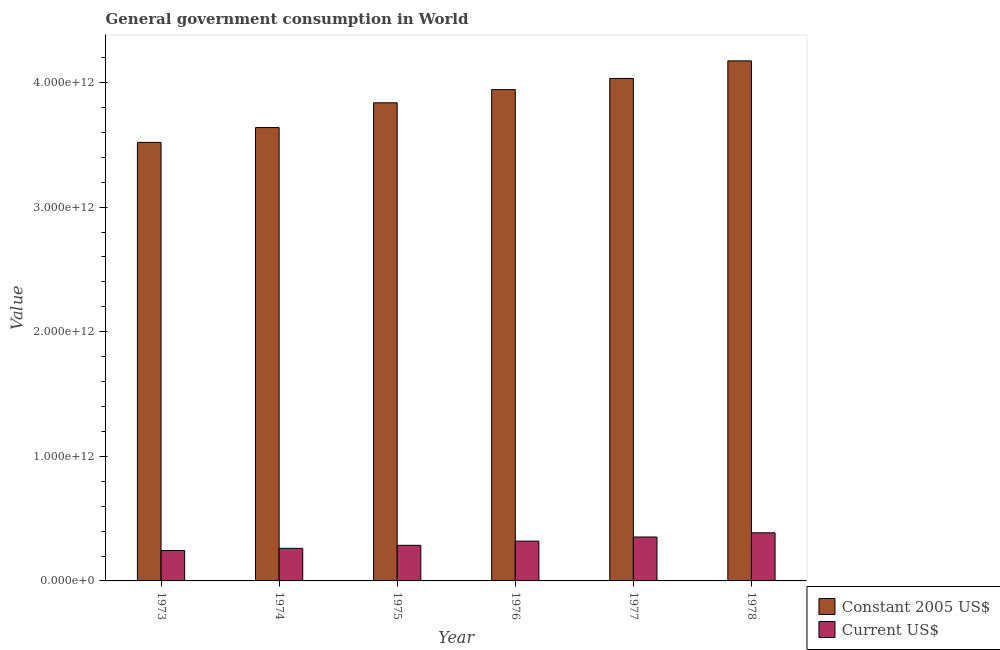Are the number of bars per tick equal to the number of legend labels?
Offer a terse response. Yes. How many bars are there on the 2nd tick from the left?
Your answer should be very brief. 2. In how many cases, is the number of bars for a given year not equal to the number of legend labels?
Keep it short and to the point. 0. What is the value consumed in constant 2005 us$ in 1977?
Provide a short and direct response. 4.03e+12. Across all years, what is the maximum value consumed in constant 2005 us$?
Your answer should be compact. 4.17e+12. Across all years, what is the minimum value consumed in current us$?
Give a very brief answer. 2.44e+11. In which year was the value consumed in current us$ maximum?
Make the answer very short. 1978. In which year was the value consumed in constant 2005 us$ minimum?
Give a very brief answer. 1973. What is the total value consumed in current us$ in the graph?
Your answer should be very brief. 1.85e+12. What is the difference between the value consumed in current us$ in 1973 and that in 1977?
Give a very brief answer. -1.08e+11. What is the difference between the value consumed in constant 2005 us$ in 1978 and the value consumed in current us$ in 1973?
Your answer should be very brief. 6.54e+11. What is the average value consumed in current us$ per year?
Offer a very short reply. 3.08e+11. In how many years, is the value consumed in constant 2005 us$ greater than 2200000000000?
Offer a very short reply. 6. What is the ratio of the value consumed in current us$ in 1973 to that in 1974?
Provide a short and direct response. 0.93. Is the difference between the value consumed in current us$ in 1973 and 1975 greater than the difference between the value consumed in constant 2005 us$ in 1973 and 1975?
Provide a short and direct response. No. What is the difference between the highest and the second highest value consumed in current us$?
Provide a succinct answer. 3.37e+1. What is the difference between the highest and the lowest value consumed in current us$?
Provide a succinct answer. 1.42e+11. Is the sum of the value consumed in constant 2005 us$ in 1973 and 1974 greater than the maximum value consumed in current us$ across all years?
Make the answer very short. Yes. What does the 1st bar from the left in 1976 represents?
Offer a very short reply. Constant 2005 US$. What does the 2nd bar from the right in 1978 represents?
Make the answer very short. Constant 2005 US$. How many bars are there?
Give a very brief answer. 12. What is the difference between two consecutive major ticks on the Y-axis?
Keep it short and to the point. 1.00e+12. Where does the legend appear in the graph?
Keep it short and to the point. Bottom right. How many legend labels are there?
Offer a terse response. 2. What is the title of the graph?
Keep it short and to the point. General government consumption in World. What is the label or title of the Y-axis?
Your answer should be very brief. Value. What is the Value of Constant 2005 US$ in 1973?
Give a very brief answer. 3.52e+12. What is the Value in Current US$ in 1973?
Provide a succinct answer. 2.44e+11. What is the Value in Constant 2005 US$ in 1974?
Offer a terse response. 3.64e+12. What is the Value of Current US$ in 1974?
Provide a succinct answer. 2.61e+11. What is the Value in Constant 2005 US$ in 1975?
Keep it short and to the point. 3.84e+12. What is the Value of Current US$ in 1975?
Offer a terse response. 2.86e+11. What is the Value in Constant 2005 US$ in 1976?
Your answer should be compact. 3.94e+12. What is the Value of Current US$ in 1976?
Your response must be concise. 3.19e+11. What is the Value of Constant 2005 US$ in 1977?
Your answer should be very brief. 4.03e+12. What is the Value of Current US$ in 1977?
Give a very brief answer. 3.52e+11. What is the Value of Constant 2005 US$ in 1978?
Make the answer very short. 4.17e+12. What is the Value in Current US$ in 1978?
Your response must be concise. 3.86e+11. Across all years, what is the maximum Value of Constant 2005 US$?
Give a very brief answer. 4.17e+12. Across all years, what is the maximum Value of Current US$?
Ensure brevity in your answer.  3.86e+11. Across all years, what is the minimum Value of Constant 2005 US$?
Provide a short and direct response. 3.52e+12. Across all years, what is the minimum Value of Current US$?
Provide a succinct answer. 2.44e+11. What is the total Value of Constant 2005 US$ in the graph?
Give a very brief answer. 2.31e+13. What is the total Value of Current US$ in the graph?
Keep it short and to the point. 1.85e+12. What is the difference between the Value in Constant 2005 US$ in 1973 and that in 1974?
Your answer should be compact. -1.19e+11. What is the difference between the Value of Current US$ in 1973 and that in 1974?
Offer a terse response. -1.73e+1. What is the difference between the Value of Constant 2005 US$ in 1973 and that in 1975?
Your answer should be compact. -3.18e+11. What is the difference between the Value of Current US$ in 1973 and that in 1975?
Offer a terse response. -4.16e+1. What is the difference between the Value in Constant 2005 US$ in 1973 and that in 1976?
Make the answer very short. -4.24e+11. What is the difference between the Value of Current US$ in 1973 and that in 1976?
Offer a terse response. -7.55e+1. What is the difference between the Value of Constant 2005 US$ in 1973 and that in 1977?
Offer a very short reply. -5.13e+11. What is the difference between the Value of Current US$ in 1973 and that in 1977?
Provide a short and direct response. -1.08e+11. What is the difference between the Value in Constant 2005 US$ in 1973 and that in 1978?
Your answer should be compact. -6.54e+11. What is the difference between the Value of Current US$ in 1973 and that in 1978?
Keep it short and to the point. -1.42e+11. What is the difference between the Value of Constant 2005 US$ in 1974 and that in 1975?
Keep it short and to the point. -1.99e+11. What is the difference between the Value in Current US$ in 1974 and that in 1975?
Offer a very short reply. -2.43e+1. What is the difference between the Value of Constant 2005 US$ in 1974 and that in 1976?
Keep it short and to the point. -3.05e+11. What is the difference between the Value of Current US$ in 1974 and that in 1976?
Keep it short and to the point. -5.81e+1. What is the difference between the Value of Constant 2005 US$ in 1974 and that in 1977?
Keep it short and to the point. -3.94e+11. What is the difference between the Value in Current US$ in 1974 and that in 1977?
Offer a very short reply. -9.11e+1. What is the difference between the Value in Constant 2005 US$ in 1974 and that in 1978?
Keep it short and to the point. -5.35e+11. What is the difference between the Value in Current US$ in 1974 and that in 1978?
Ensure brevity in your answer.  -1.25e+11. What is the difference between the Value of Constant 2005 US$ in 1975 and that in 1976?
Your answer should be very brief. -1.06e+11. What is the difference between the Value of Current US$ in 1975 and that in 1976?
Ensure brevity in your answer.  -3.38e+1. What is the difference between the Value in Constant 2005 US$ in 1975 and that in 1977?
Keep it short and to the point. -1.95e+11. What is the difference between the Value in Current US$ in 1975 and that in 1977?
Provide a short and direct response. -6.68e+1. What is the difference between the Value in Constant 2005 US$ in 1975 and that in 1978?
Offer a very short reply. -3.36e+11. What is the difference between the Value of Current US$ in 1975 and that in 1978?
Give a very brief answer. -1.00e+11. What is the difference between the Value of Constant 2005 US$ in 1976 and that in 1977?
Provide a short and direct response. -8.95e+1. What is the difference between the Value in Current US$ in 1976 and that in 1977?
Make the answer very short. -3.30e+1. What is the difference between the Value of Constant 2005 US$ in 1976 and that in 1978?
Ensure brevity in your answer.  -2.31e+11. What is the difference between the Value of Current US$ in 1976 and that in 1978?
Keep it short and to the point. -6.67e+1. What is the difference between the Value of Constant 2005 US$ in 1977 and that in 1978?
Your answer should be very brief. -1.41e+11. What is the difference between the Value in Current US$ in 1977 and that in 1978?
Give a very brief answer. -3.37e+1. What is the difference between the Value in Constant 2005 US$ in 1973 and the Value in Current US$ in 1974?
Provide a succinct answer. 3.26e+12. What is the difference between the Value of Constant 2005 US$ in 1973 and the Value of Current US$ in 1975?
Keep it short and to the point. 3.23e+12. What is the difference between the Value in Constant 2005 US$ in 1973 and the Value in Current US$ in 1976?
Ensure brevity in your answer.  3.20e+12. What is the difference between the Value in Constant 2005 US$ in 1973 and the Value in Current US$ in 1977?
Provide a short and direct response. 3.17e+12. What is the difference between the Value in Constant 2005 US$ in 1973 and the Value in Current US$ in 1978?
Keep it short and to the point. 3.13e+12. What is the difference between the Value of Constant 2005 US$ in 1974 and the Value of Current US$ in 1975?
Offer a terse response. 3.35e+12. What is the difference between the Value of Constant 2005 US$ in 1974 and the Value of Current US$ in 1976?
Provide a succinct answer. 3.32e+12. What is the difference between the Value in Constant 2005 US$ in 1974 and the Value in Current US$ in 1977?
Your response must be concise. 3.29e+12. What is the difference between the Value in Constant 2005 US$ in 1974 and the Value in Current US$ in 1978?
Give a very brief answer. 3.25e+12. What is the difference between the Value in Constant 2005 US$ in 1975 and the Value in Current US$ in 1976?
Provide a short and direct response. 3.52e+12. What is the difference between the Value in Constant 2005 US$ in 1975 and the Value in Current US$ in 1977?
Your answer should be very brief. 3.48e+12. What is the difference between the Value in Constant 2005 US$ in 1975 and the Value in Current US$ in 1978?
Offer a terse response. 3.45e+12. What is the difference between the Value in Constant 2005 US$ in 1976 and the Value in Current US$ in 1977?
Keep it short and to the point. 3.59e+12. What is the difference between the Value of Constant 2005 US$ in 1976 and the Value of Current US$ in 1978?
Provide a short and direct response. 3.56e+12. What is the difference between the Value of Constant 2005 US$ in 1977 and the Value of Current US$ in 1978?
Provide a short and direct response. 3.65e+12. What is the average Value in Constant 2005 US$ per year?
Offer a terse response. 3.86e+12. What is the average Value of Current US$ per year?
Your answer should be very brief. 3.08e+11. In the year 1973, what is the difference between the Value of Constant 2005 US$ and Value of Current US$?
Provide a short and direct response. 3.28e+12. In the year 1974, what is the difference between the Value of Constant 2005 US$ and Value of Current US$?
Give a very brief answer. 3.38e+12. In the year 1975, what is the difference between the Value of Constant 2005 US$ and Value of Current US$?
Provide a short and direct response. 3.55e+12. In the year 1976, what is the difference between the Value of Constant 2005 US$ and Value of Current US$?
Your answer should be very brief. 3.62e+12. In the year 1977, what is the difference between the Value of Constant 2005 US$ and Value of Current US$?
Ensure brevity in your answer.  3.68e+12. In the year 1978, what is the difference between the Value of Constant 2005 US$ and Value of Current US$?
Provide a short and direct response. 3.79e+12. What is the ratio of the Value of Constant 2005 US$ in 1973 to that in 1974?
Give a very brief answer. 0.97. What is the ratio of the Value in Current US$ in 1973 to that in 1974?
Your answer should be very brief. 0.93. What is the ratio of the Value in Constant 2005 US$ in 1973 to that in 1975?
Offer a terse response. 0.92. What is the ratio of the Value of Current US$ in 1973 to that in 1975?
Offer a very short reply. 0.85. What is the ratio of the Value in Constant 2005 US$ in 1973 to that in 1976?
Ensure brevity in your answer.  0.89. What is the ratio of the Value in Current US$ in 1973 to that in 1976?
Offer a terse response. 0.76. What is the ratio of the Value of Constant 2005 US$ in 1973 to that in 1977?
Ensure brevity in your answer.  0.87. What is the ratio of the Value in Current US$ in 1973 to that in 1977?
Provide a succinct answer. 0.69. What is the ratio of the Value in Constant 2005 US$ in 1973 to that in 1978?
Give a very brief answer. 0.84. What is the ratio of the Value in Current US$ in 1973 to that in 1978?
Give a very brief answer. 0.63. What is the ratio of the Value of Constant 2005 US$ in 1974 to that in 1975?
Make the answer very short. 0.95. What is the ratio of the Value in Current US$ in 1974 to that in 1975?
Provide a short and direct response. 0.91. What is the ratio of the Value of Constant 2005 US$ in 1974 to that in 1976?
Make the answer very short. 0.92. What is the ratio of the Value in Current US$ in 1974 to that in 1976?
Offer a terse response. 0.82. What is the ratio of the Value of Constant 2005 US$ in 1974 to that in 1977?
Give a very brief answer. 0.9. What is the ratio of the Value in Current US$ in 1974 to that in 1977?
Provide a succinct answer. 0.74. What is the ratio of the Value of Constant 2005 US$ in 1974 to that in 1978?
Ensure brevity in your answer.  0.87. What is the ratio of the Value of Current US$ in 1974 to that in 1978?
Offer a very short reply. 0.68. What is the ratio of the Value in Constant 2005 US$ in 1975 to that in 1976?
Ensure brevity in your answer.  0.97. What is the ratio of the Value in Current US$ in 1975 to that in 1976?
Provide a short and direct response. 0.89. What is the ratio of the Value of Constant 2005 US$ in 1975 to that in 1977?
Provide a succinct answer. 0.95. What is the ratio of the Value of Current US$ in 1975 to that in 1977?
Ensure brevity in your answer.  0.81. What is the ratio of the Value of Constant 2005 US$ in 1975 to that in 1978?
Provide a short and direct response. 0.92. What is the ratio of the Value in Current US$ in 1975 to that in 1978?
Make the answer very short. 0.74. What is the ratio of the Value in Constant 2005 US$ in 1976 to that in 1977?
Your response must be concise. 0.98. What is the ratio of the Value of Current US$ in 1976 to that in 1977?
Make the answer very short. 0.91. What is the ratio of the Value in Constant 2005 US$ in 1976 to that in 1978?
Your answer should be very brief. 0.94. What is the ratio of the Value of Current US$ in 1976 to that in 1978?
Offer a terse response. 0.83. What is the ratio of the Value in Constant 2005 US$ in 1977 to that in 1978?
Keep it short and to the point. 0.97. What is the ratio of the Value of Current US$ in 1977 to that in 1978?
Provide a short and direct response. 0.91. What is the difference between the highest and the second highest Value of Constant 2005 US$?
Offer a terse response. 1.41e+11. What is the difference between the highest and the second highest Value of Current US$?
Your answer should be very brief. 3.37e+1. What is the difference between the highest and the lowest Value of Constant 2005 US$?
Give a very brief answer. 6.54e+11. What is the difference between the highest and the lowest Value of Current US$?
Keep it short and to the point. 1.42e+11. 